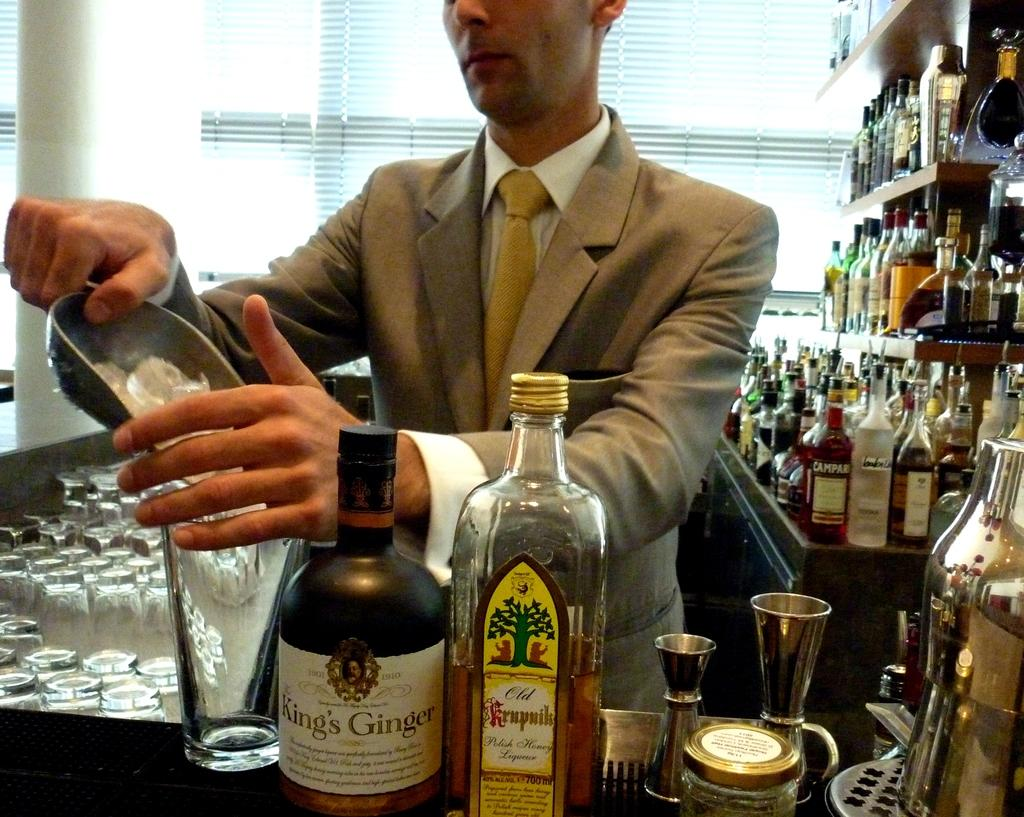<image>
Offer a succinct explanation of the picture presented. A bottle with King's Ginger written on it at a bar. 